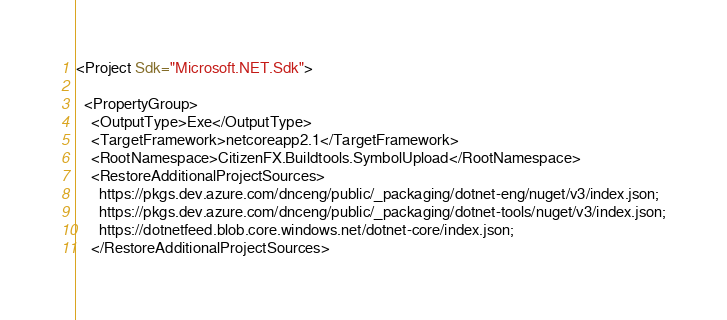<code> <loc_0><loc_0><loc_500><loc_500><_XML_><Project Sdk="Microsoft.NET.Sdk">

  <PropertyGroup>
    <OutputType>Exe</OutputType>
    <TargetFramework>netcoreapp2.1</TargetFramework>
    <RootNamespace>CitizenFX.Buildtools.SymbolUpload</RootNamespace>
    <RestoreAdditionalProjectSources>
      https://pkgs.dev.azure.com/dnceng/public/_packaging/dotnet-eng/nuget/v3/index.json;
      https://pkgs.dev.azure.com/dnceng/public/_packaging/dotnet-tools/nuget/v3/index.json;
      https://dotnetfeed.blob.core.windows.net/dotnet-core/index.json;
    </RestoreAdditionalProjectSources></code> 